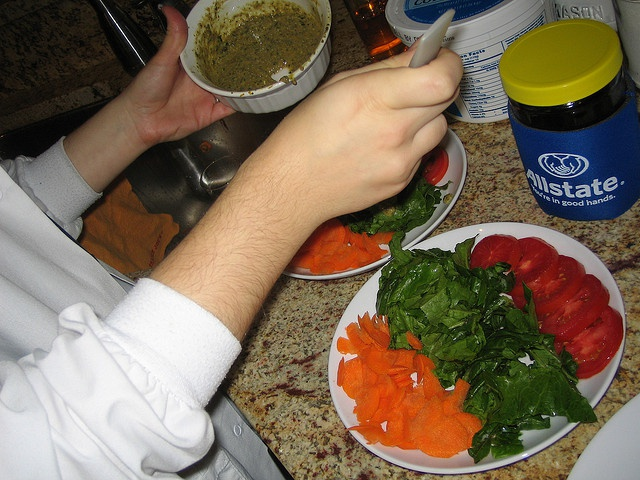Describe the objects in this image and their specific colors. I can see people in black, lightgray, darkgray, tan, and gray tones, carrot in black, red, brown, and maroon tones, and bowl in black, olive, and gray tones in this image. 